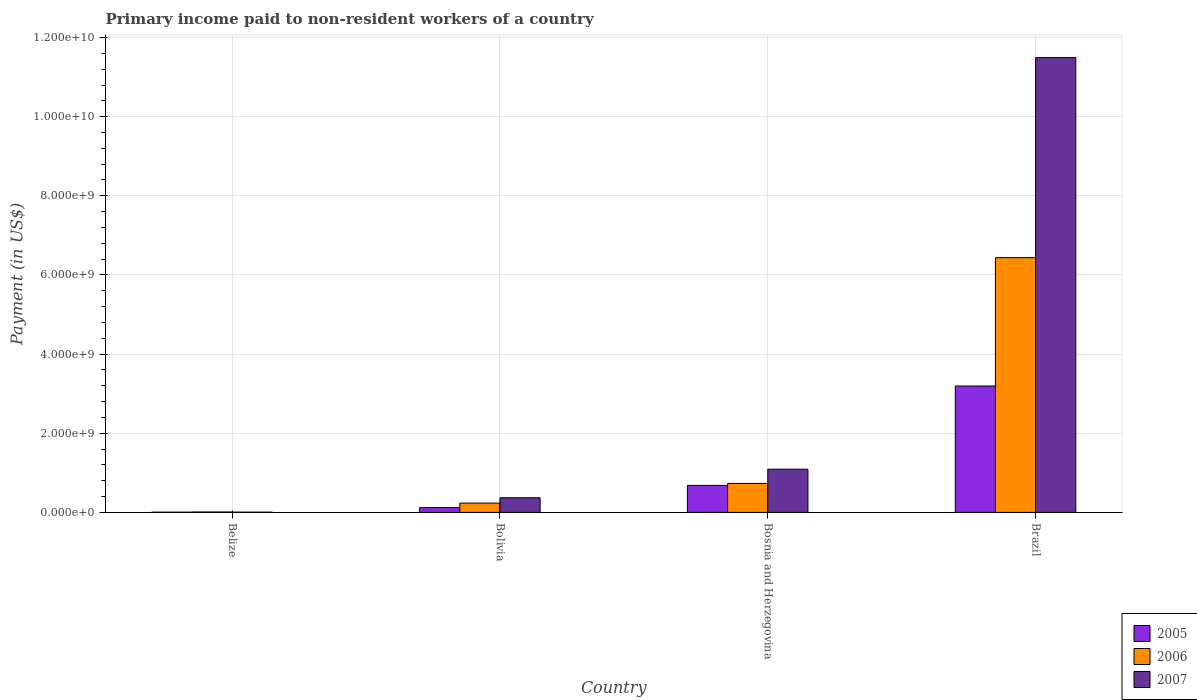Are the number of bars per tick equal to the number of legend labels?
Your answer should be very brief. Yes. Are the number of bars on each tick of the X-axis equal?
Offer a terse response. Yes. How many bars are there on the 3rd tick from the right?
Your answer should be very brief. 3. What is the label of the 4th group of bars from the left?
Give a very brief answer. Brazil. What is the amount paid to workers in 2005 in Bosnia and Herzegovina?
Give a very brief answer. 6.82e+08. Across all countries, what is the maximum amount paid to workers in 2005?
Keep it short and to the point. 3.19e+09. Across all countries, what is the minimum amount paid to workers in 2006?
Provide a short and direct response. 1.01e+07. In which country was the amount paid to workers in 2005 minimum?
Your answer should be compact. Belize. What is the total amount paid to workers in 2006 in the graph?
Ensure brevity in your answer.  7.42e+09. What is the difference between the amount paid to workers in 2006 in Belize and that in Brazil?
Offer a very short reply. -6.43e+09. What is the difference between the amount paid to workers in 2007 in Belize and the amount paid to workers in 2005 in Brazil?
Your response must be concise. -3.19e+09. What is the average amount paid to workers in 2006 per country?
Provide a short and direct response. 1.85e+09. What is the difference between the amount paid to workers of/in 2005 and amount paid to workers of/in 2007 in Bosnia and Herzegovina?
Offer a very short reply. -4.10e+08. What is the ratio of the amount paid to workers in 2005 in Bolivia to that in Brazil?
Your answer should be very brief. 0.04. What is the difference between the highest and the second highest amount paid to workers in 2006?
Ensure brevity in your answer.  -6.20e+09. What is the difference between the highest and the lowest amount paid to workers in 2005?
Give a very brief answer. 3.19e+09. What does the 2nd bar from the right in Bolivia represents?
Your answer should be compact. 2006. How many bars are there?
Give a very brief answer. 12. Are all the bars in the graph horizontal?
Provide a short and direct response. No. What is the difference between two consecutive major ticks on the Y-axis?
Your answer should be compact. 2.00e+09. What is the title of the graph?
Provide a short and direct response. Primary income paid to non-resident workers of a country. What is the label or title of the X-axis?
Your response must be concise. Country. What is the label or title of the Y-axis?
Ensure brevity in your answer.  Payment (in US$). What is the Payment (in US$) in 2005 in Belize?
Make the answer very short. 6.78e+06. What is the Payment (in US$) of 2006 in Belize?
Make the answer very short. 1.01e+07. What is the Payment (in US$) of 2007 in Belize?
Ensure brevity in your answer.  6.97e+06. What is the Payment (in US$) of 2005 in Bolivia?
Keep it short and to the point. 1.21e+08. What is the Payment (in US$) in 2006 in Bolivia?
Your answer should be very brief. 2.35e+08. What is the Payment (in US$) in 2007 in Bolivia?
Make the answer very short. 3.70e+08. What is the Payment (in US$) in 2005 in Bosnia and Herzegovina?
Make the answer very short. 6.82e+08. What is the Payment (in US$) in 2006 in Bosnia and Herzegovina?
Ensure brevity in your answer.  7.33e+08. What is the Payment (in US$) in 2007 in Bosnia and Herzegovina?
Provide a succinct answer. 1.09e+09. What is the Payment (in US$) in 2005 in Brazil?
Keep it short and to the point. 3.19e+09. What is the Payment (in US$) in 2006 in Brazil?
Offer a terse response. 6.44e+09. What is the Payment (in US$) in 2007 in Brazil?
Your answer should be very brief. 1.15e+1. Across all countries, what is the maximum Payment (in US$) of 2005?
Provide a short and direct response. 3.19e+09. Across all countries, what is the maximum Payment (in US$) in 2006?
Ensure brevity in your answer.  6.44e+09. Across all countries, what is the maximum Payment (in US$) of 2007?
Keep it short and to the point. 1.15e+1. Across all countries, what is the minimum Payment (in US$) of 2005?
Offer a terse response. 6.78e+06. Across all countries, what is the minimum Payment (in US$) of 2006?
Ensure brevity in your answer.  1.01e+07. Across all countries, what is the minimum Payment (in US$) of 2007?
Provide a short and direct response. 6.97e+06. What is the total Payment (in US$) in 2005 in the graph?
Ensure brevity in your answer.  4.00e+09. What is the total Payment (in US$) in 2006 in the graph?
Provide a short and direct response. 7.42e+09. What is the total Payment (in US$) of 2007 in the graph?
Your answer should be very brief. 1.30e+1. What is the difference between the Payment (in US$) in 2005 in Belize and that in Bolivia?
Make the answer very short. -1.14e+08. What is the difference between the Payment (in US$) of 2006 in Belize and that in Bolivia?
Make the answer very short. -2.25e+08. What is the difference between the Payment (in US$) of 2007 in Belize and that in Bolivia?
Ensure brevity in your answer.  -3.63e+08. What is the difference between the Payment (in US$) in 2005 in Belize and that in Bosnia and Herzegovina?
Your answer should be very brief. -6.76e+08. What is the difference between the Payment (in US$) in 2006 in Belize and that in Bosnia and Herzegovina?
Provide a short and direct response. -7.22e+08. What is the difference between the Payment (in US$) in 2007 in Belize and that in Bosnia and Herzegovina?
Your answer should be compact. -1.08e+09. What is the difference between the Payment (in US$) of 2005 in Belize and that in Brazil?
Provide a succinct answer. -3.19e+09. What is the difference between the Payment (in US$) in 2006 in Belize and that in Brazil?
Give a very brief answer. -6.43e+09. What is the difference between the Payment (in US$) in 2007 in Belize and that in Brazil?
Make the answer very short. -1.15e+1. What is the difference between the Payment (in US$) of 2005 in Bolivia and that in Bosnia and Herzegovina?
Provide a succinct answer. -5.61e+08. What is the difference between the Payment (in US$) in 2006 in Bolivia and that in Bosnia and Herzegovina?
Provide a succinct answer. -4.97e+08. What is the difference between the Payment (in US$) of 2007 in Bolivia and that in Bosnia and Herzegovina?
Provide a short and direct response. -7.22e+08. What is the difference between the Payment (in US$) in 2005 in Bolivia and that in Brazil?
Keep it short and to the point. -3.07e+09. What is the difference between the Payment (in US$) of 2006 in Bolivia and that in Brazil?
Give a very brief answer. -6.20e+09. What is the difference between the Payment (in US$) of 2007 in Bolivia and that in Brazil?
Provide a short and direct response. -1.11e+1. What is the difference between the Payment (in US$) of 2005 in Bosnia and Herzegovina and that in Brazil?
Offer a terse response. -2.51e+09. What is the difference between the Payment (in US$) of 2006 in Bosnia and Herzegovina and that in Brazil?
Provide a succinct answer. -5.71e+09. What is the difference between the Payment (in US$) of 2007 in Bosnia and Herzegovina and that in Brazil?
Your answer should be very brief. -1.04e+1. What is the difference between the Payment (in US$) of 2005 in Belize and the Payment (in US$) of 2006 in Bolivia?
Make the answer very short. -2.29e+08. What is the difference between the Payment (in US$) of 2005 in Belize and the Payment (in US$) of 2007 in Bolivia?
Ensure brevity in your answer.  -3.63e+08. What is the difference between the Payment (in US$) in 2006 in Belize and the Payment (in US$) in 2007 in Bolivia?
Give a very brief answer. -3.60e+08. What is the difference between the Payment (in US$) in 2005 in Belize and the Payment (in US$) in 2006 in Bosnia and Herzegovina?
Offer a very short reply. -7.26e+08. What is the difference between the Payment (in US$) of 2005 in Belize and the Payment (in US$) of 2007 in Bosnia and Herzegovina?
Your response must be concise. -1.09e+09. What is the difference between the Payment (in US$) in 2006 in Belize and the Payment (in US$) in 2007 in Bosnia and Herzegovina?
Your answer should be very brief. -1.08e+09. What is the difference between the Payment (in US$) in 2005 in Belize and the Payment (in US$) in 2006 in Brazil?
Provide a succinct answer. -6.43e+09. What is the difference between the Payment (in US$) of 2005 in Belize and the Payment (in US$) of 2007 in Brazil?
Make the answer very short. -1.15e+1. What is the difference between the Payment (in US$) in 2006 in Belize and the Payment (in US$) in 2007 in Brazil?
Your response must be concise. -1.15e+1. What is the difference between the Payment (in US$) of 2005 in Bolivia and the Payment (in US$) of 2006 in Bosnia and Herzegovina?
Provide a short and direct response. -6.11e+08. What is the difference between the Payment (in US$) in 2005 in Bolivia and the Payment (in US$) in 2007 in Bosnia and Herzegovina?
Your answer should be compact. -9.71e+08. What is the difference between the Payment (in US$) in 2006 in Bolivia and the Payment (in US$) in 2007 in Bosnia and Herzegovina?
Offer a terse response. -8.56e+08. What is the difference between the Payment (in US$) of 2005 in Bolivia and the Payment (in US$) of 2006 in Brazil?
Offer a terse response. -6.32e+09. What is the difference between the Payment (in US$) of 2005 in Bolivia and the Payment (in US$) of 2007 in Brazil?
Keep it short and to the point. -1.14e+1. What is the difference between the Payment (in US$) in 2006 in Bolivia and the Payment (in US$) in 2007 in Brazil?
Ensure brevity in your answer.  -1.13e+1. What is the difference between the Payment (in US$) in 2005 in Bosnia and Herzegovina and the Payment (in US$) in 2006 in Brazil?
Provide a short and direct response. -5.76e+09. What is the difference between the Payment (in US$) in 2005 in Bosnia and Herzegovina and the Payment (in US$) in 2007 in Brazil?
Provide a short and direct response. -1.08e+1. What is the difference between the Payment (in US$) of 2006 in Bosnia and Herzegovina and the Payment (in US$) of 2007 in Brazil?
Make the answer very short. -1.08e+1. What is the average Payment (in US$) of 2005 per country?
Offer a terse response. 1.00e+09. What is the average Payment (in US$) in 2006 per country?
Your answer should be compact. 1.85e+09. What is the average Payment (in US$) of 2007 per country?
Your response must be concise. 3.24e+09. What is the difference between the Payment (in US$) in 2005 and Payment (in US$) in 2006 in Belize?
Provide a succinct answer. -3.32e+06. What is the difference between the Payment (in US$) of 2005 and Payment (in US$) of 2007 in Belize?
Keep it short and to the point. -1.86e+05. What is the difference between the Payment (in US$) in 2006 and Payment (in US$) in 2007 in Belize?
Your answer should be compact. 3.13e+06. What is the difference between the Payment (in US$) of 2005 and Payment (in US$) of 2006 in Bolivia?
Your answer should be compact. -1.14e+08. What is the difference between the Payment (in US$) of 2005 and Payment (in US$) of 2007 in Bolivia?
Ensure brevity in your answer.  -2.49e+08. What is the difference between the Payment (in US$) of 2006 and Payment (in US$) of 2007 in Bolivia?
Your answer should be compact. -1.34e+08. What is the difference between the Payment (in US$) of 2005 and Payment (in US$) of 2006 in Bosnia and Herzegovina?
Provide a succinct answer. -5.03e+07. What is the difference between the Payment (in US$) of 2005 and Payment (in US$) of 2007 in Bosnia and Herzegovina?
Provide a short and direct response. -4.10e+08. What is the difference between the Payment (in US$) in 2006 and Payment (in US$) in 2007 in Bosnia and Herzegovina?
Offer a very short reply. -3.59e+08. What is the difference between the Payment (in US$) of 2005 and Payment (in US$) of 2006 in Brazil?
Keep it short and to the point. -3.24e+09. What is the difference between the Payment (in US$) of 2005 and Payment (in US$) of 2007 in Brazil?
Make the answer very short. -8.30e+09. What is the difference between the Payment (in US$) of 2006 and Payment (in US$) of 2007 in Brazil?
Keep it short and to the point. -5.05e+09. What is the ratio of the Payment (in US$) in 2005 in Belize to that in Bolivia?
Give a very brief answer. 0.06. What is the ratio of the Payment (in US$) of 2006 in Belize to that in Bolivia?
Ensure brevity in your answer.  0.04. What is the ratio of the Payment (in US$) of 2007 in Belize to that in Bolivia?
Your response must be concise. 0.02. What is the ratio of the Payment (in US$) of 2005 in Belize to that in Bosnia and Herzegovina?
Your answer should be compact. 0.01. What is the ratio of the Payment (in US$) in 2006 in Belize to that in Bosnia and Herzegovina?
Provide a short and direct response. 0.01. What is the ratio of the Payment (in US$) in 2007 in Belize to that in Bosnia and Herzegovina?
Provide a short and direct response. 0.01. What is the ratio of the Payment (in US$) in 2005 in Belize to that in Brazil?
Your answer should be very brief. 0. What is the ratio of the Payment (in US$) in 2006 in Belize to that in Brazil?
Keep it short and to the point. 0. What is the ratio of the Payment (in US$) in 2007 in Belize to that in Brazil?
Offer a terse response. 0. What is the ratio of the Payment (in US$) in 2005 in Bolivia to that in Bosnia and Herzegovina?
Give a very brief answer. 0.18. What is the ratio of the Payment (in US$) of 2006 in Bolivia to that in Bosnia and Herzegovina?
Provide a succinct answer. 0.32. What is the ratio of the Payment (in US$) in 2007 in Bolivia to that in Bosnia and Herzegovina?
Keep it short and to the point. 0.34. What is the ratio of the Payment (in US$) in 2005 in Bolivia to that in Brazil?
Give a very brief answer. 0.04. What is the ratio of the Payment (in US$) of 2006 in Bolivia to that in Brazil?
Provide a short and direct response. 0.04. What is the ratio of the Payment (in US$) in 2007 in Bolivia to that in Brazil?
Your answer should be very brief. 0.03. What is the ratio of the Payment (in US$) of 2005 in Bosnia and Herzegovina to that in Brazil?
Give a very brief answer. 0.21. What is the ratio of the Payment (in US$) of 2006 in Bosnia and Herzegovina to that in Brazil?
Your answer should be very brief. 0.11. What is the ratio of the Payment (in US$) of 2007 in Bosnia and Herzegovina to that in Brazil?
Offer a very short reply. 0.1. What is the difference between the highest and the second highest Payment (in US$) in 2005?
Provide a succinct answer. 2.51e+09. What is the difference between the highest and the second highest Payment (in US$) in 2006?
Make the answer very short. 5.71e+09. What is the difference between the highest and the second highest Payment (in US$) of 2007?
Your response must be concise. 1.04e+1. What is the difference between the highest and the lowest Payment (in US$) of 2005?
Provide a short and direct response. 3.19e+09. What is the difference between the highest and the lowest Payment (in US$) in 2006?
Give a very brief answer. 6.43e+09. What is the difference between the highest and the lowest Payment (in US$) in 2007?
Your answer should be compact. 1.15e+1. 